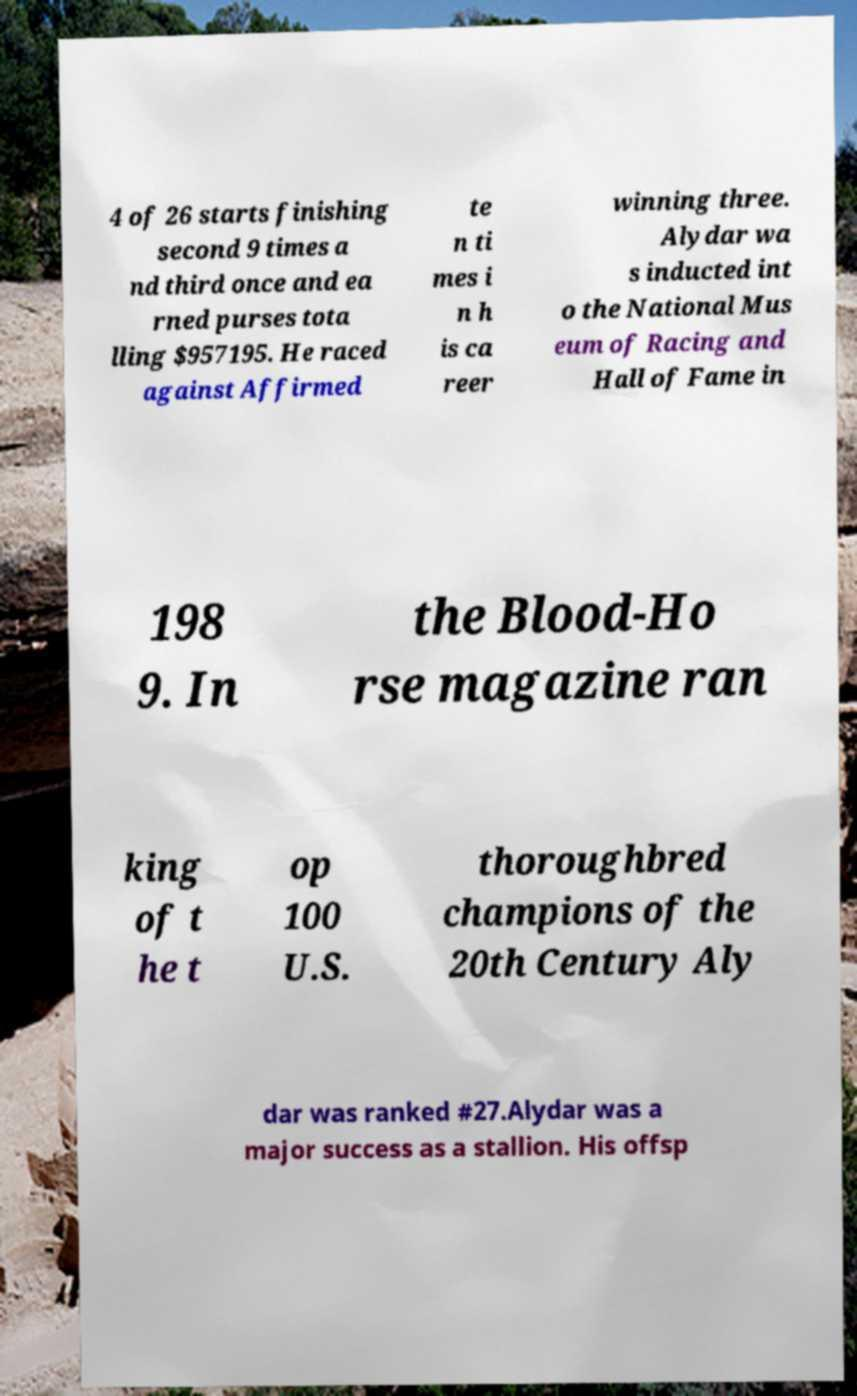Can you read and provide the text displayed in the image?This photo seems to have some interesting text. Can you extract and type it out for me? 4 of 26 starts finishing second 9 times a nd third once and ea rned purses tota lling $957195. He raced against Affirmed te n ti mes i n h is ca reer winning three. Alydar wa s inducted int o the National Mus eum of Racing and Hall of Fame in 198 9. In the Blood-Ho rse magazine ran king of t he t op 100 U.S. thoroughbred champions of the 20th Century Aly dar was ranked #27.Alydar was a major success as a stallion. His offsp 